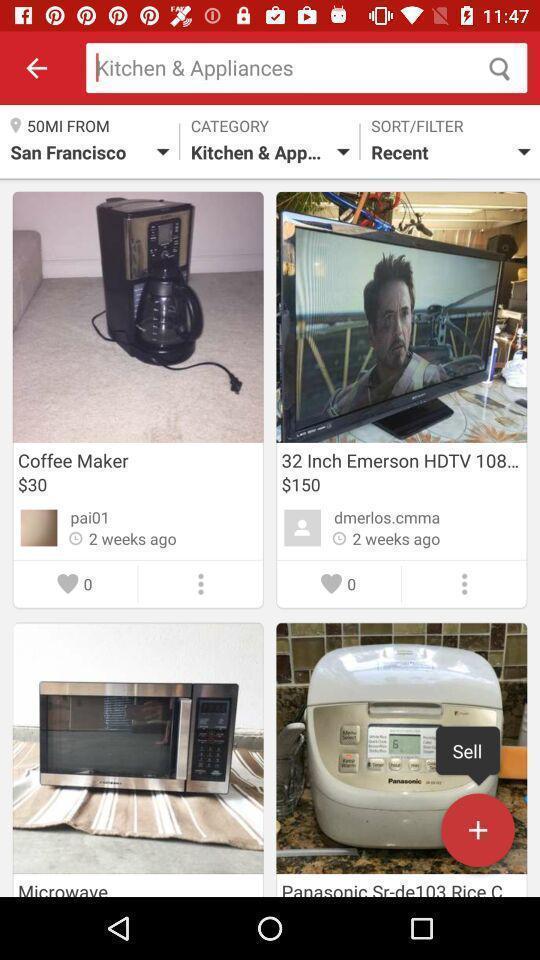Summarize the information in this screenshot. Screen displaying the products in kitchen appliances page. 